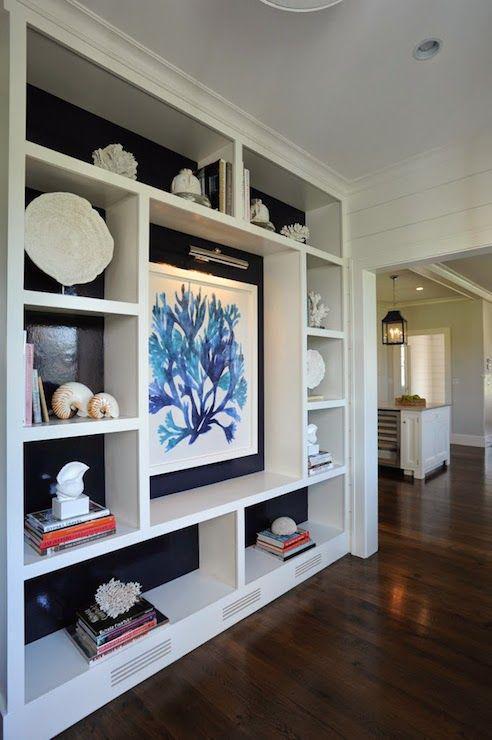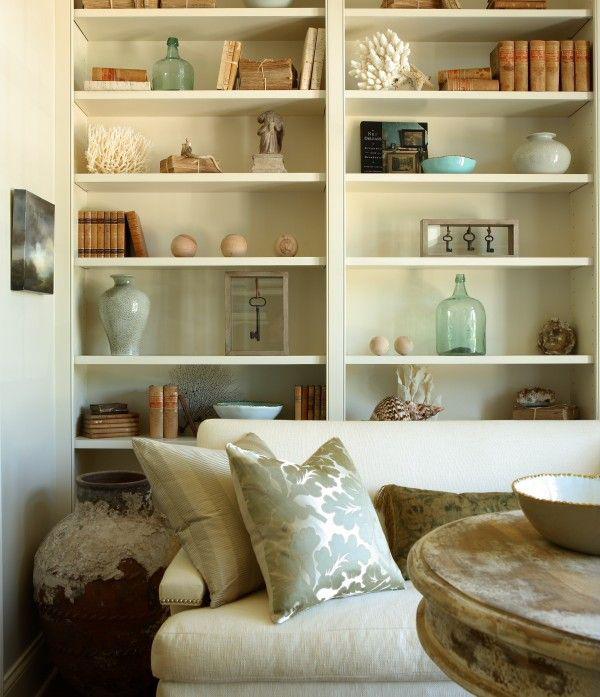The first image is the image on the left, the second image is the image on the right. For the images shown, is this caption "There is a TV above a fireplace in the right image." true? Answer yes or no. No. The first image is the image on the left, the second image is the image on the right. For the images displayed, is the sentence "In at least one image, a fireplace with an overhead television is flanked by shelves." factually correct? Answer yes or no. No. 